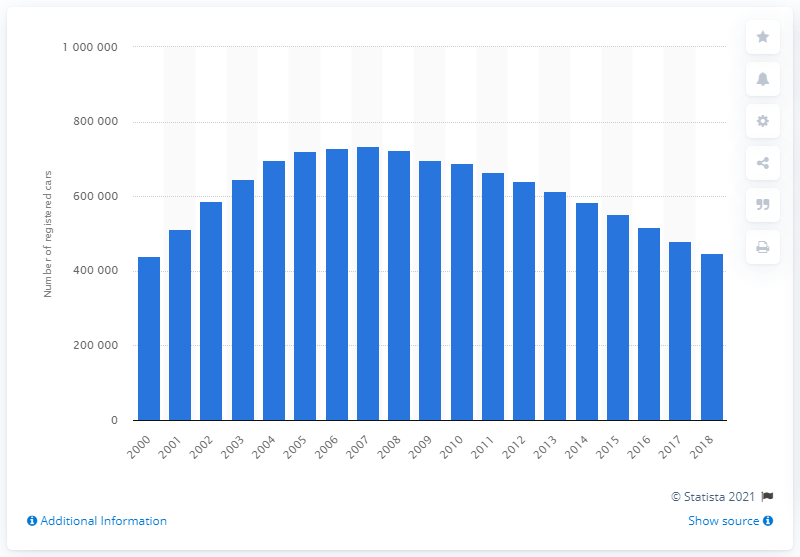Point out several critical features in this image. In 2018, there were approximately 447,971 Renault Clio cars registered on the roads in the United Kingdom. In 2007, the peak number of registered Renault Clio cars was 733,632. 